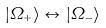Convert formula to latex. <formula><loc_0><loc_0><loc_500><loc_500>| \Omega _ { + } \rangle \leftrightarrow | \Omega _ { - } \rangle</formula> 